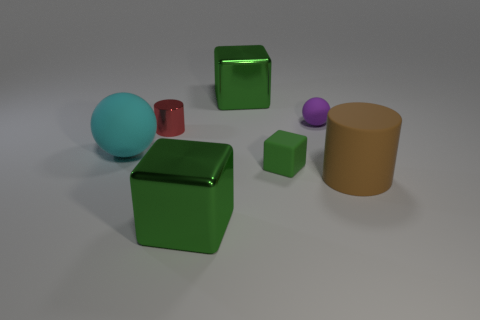Which object seems to be at the foreground of this arrangement? The foreground of the image is occupied by the green shiny cube, which is prominent and central in the arrangement, drawing immediate focus due to its size and positioning. Is there any pattern in how the objects are arranged? The objects do not appear to follow any specific pattern. They are arranged in an arbitrary positioning with varying distances from each other, suggesting a random placement rather than a deliberate pattern. 